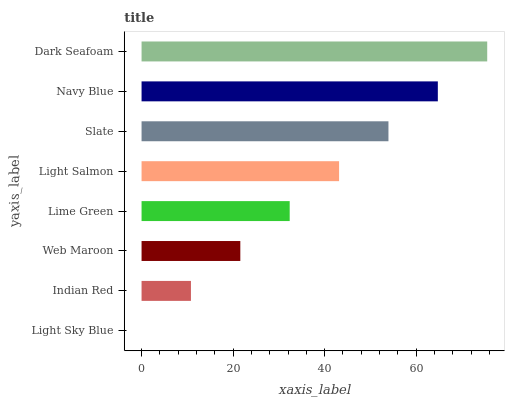Is Light Sky Blue the minimum?
Answer yes or no. Yes. Is Dark Seafoam the maximum?
Answer yes or no. Yes. Is Indian Red the minimum?
Answer yes or no. No. Is Indian Red the maximum?
Answer yes or no. No. Is Indian Red greater than Light Sky Blue?
Answer yes or no. Yes. Is Light Sky Blue less than Indian Red?
Answer yes or no. Yes. Is Light Sky Blue greater than Indian Red?
Answer yes or no. No. Is Indian Red less than Light Sky Blue?
Answer yes or no. No. Is Light Salmon the high median?
Answer yes or no. Yes. Is Lime Green the low median?
Answer yes or no. Yes. Is Dark Seafoam the high median?
Answer yes or no. No. Is Light Sky Blue the low median?
Answer yes or no. No. 